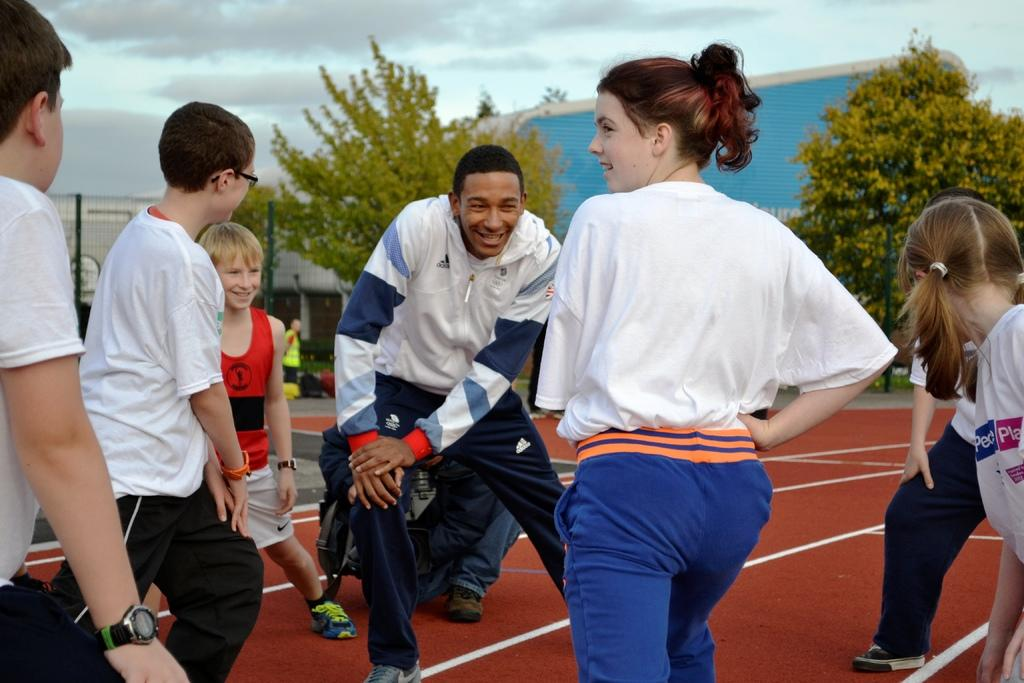How many people are in the image? There are people in the image, but the exact number is not specified. What are the people doing in the image? The people are on a surface, but their specific activity is not mentioned. What is on the left side of the image? There is a metal grill fence on the left side of the image. What type of vegetation can be seen in the image? There are trees visible in the image. What structure is visible in the background of the image? There is a shed in the background of the image. What is visible in the sky in the image? Clouds are present in the sky. What type of cherry is being used as a ship's anchor in the image? There is no cherry or ship present in the image, so it is not possible to answer that question. 